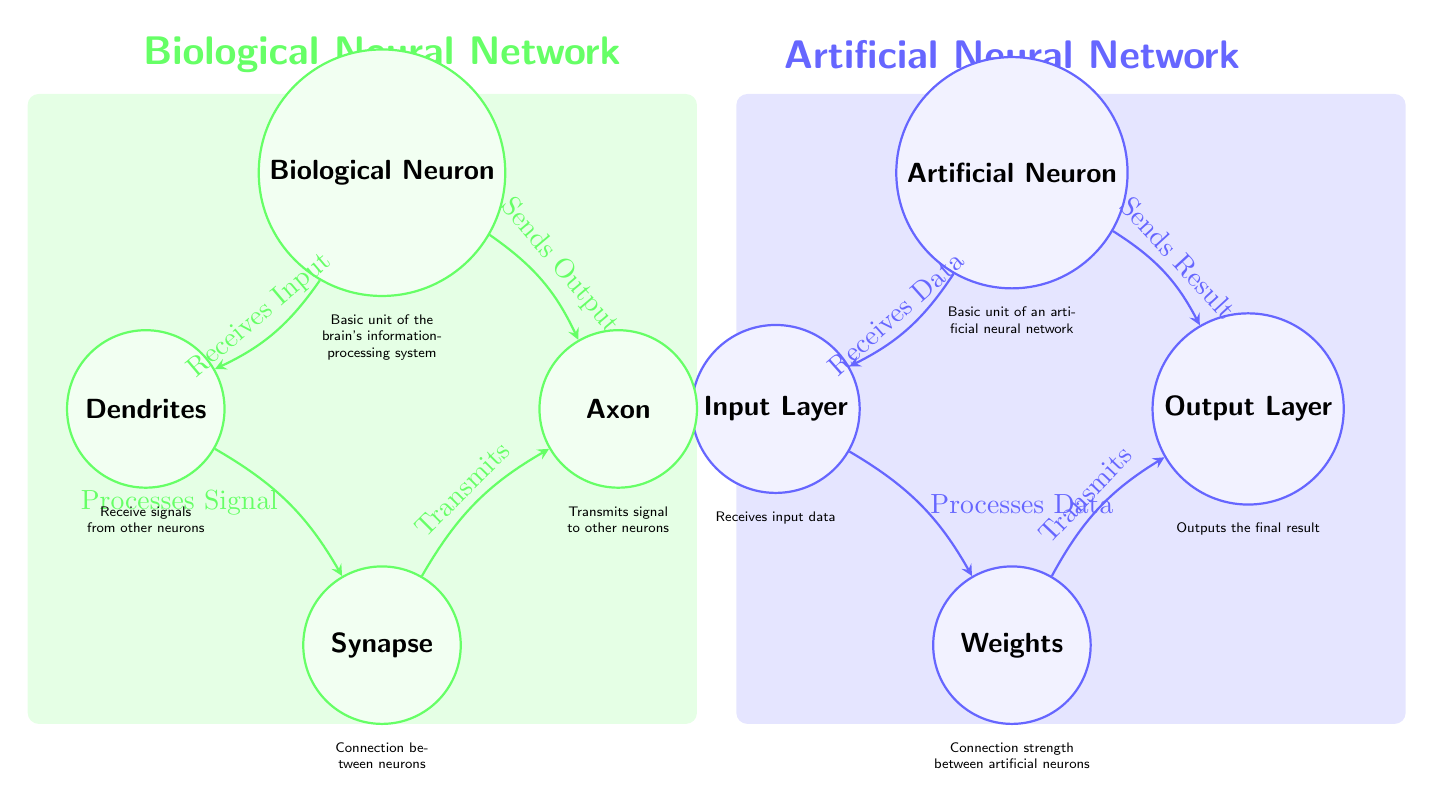What are the two main types of neurons represented in the diagram? The diagram distinguishes between Biological Neuron and Artificial Neuron, which are labeled in the upper sections of the diagram.
Answer: Biological Neuron, Artificial Neuron What part of the biological neuron receives signals? The diagram shows that Dendrites are the part of the biological neuron that receives signals from other neurons, as indicated by the flow from the Biological Neuron to the Dendrites.
Answer: Dendrites What is the equivalent of the synapse in artificial neurons? According to the diagram, the equivalent of Synapse in artificial neurons is Weights, as indicated by the connection in the structure of artificial neurons.
Answer: Weights How many connections are there between biological and artificial neurons? The diagram shows four direct connections (edges) between the biological neuron structure and the artificial neuron structure, indicating the interactions and equivalences between them.
Answer: Four What function does the synapse perform in the biological neuron? The diagram indicates that the Synapse transmits signals to other neurons, showing its role as a connection point between biological neurons.
Answer: Transmits What is processed in the input layer of an artificial neuron? The diagram specifies that the Input Layer processes data, highlighting its primary function in the flow of the artificial neuron.
Answer: Data Which component of the biological neuron processes signals? The diagram shows that the Axon is responsible for processing signals before they are sent out, as depicted by the connecting arrow from Dendrites to Axon.
Answer: Axon In the context of the diagram, what does the term "Sends Output" refer to? The term "Sends Output" in the diagram refers to the function of the Axon in the biological neuron, which transmits signals after processing, as shown by the connection from the Axon back to the synapse.
Answer: Sends Output What is the role of the weights in artificial neurons? The diagram indicates that Weights define the connection strength between artificial neurons, crucial for determining the output based on the processed data.
Answer: Connection strength 